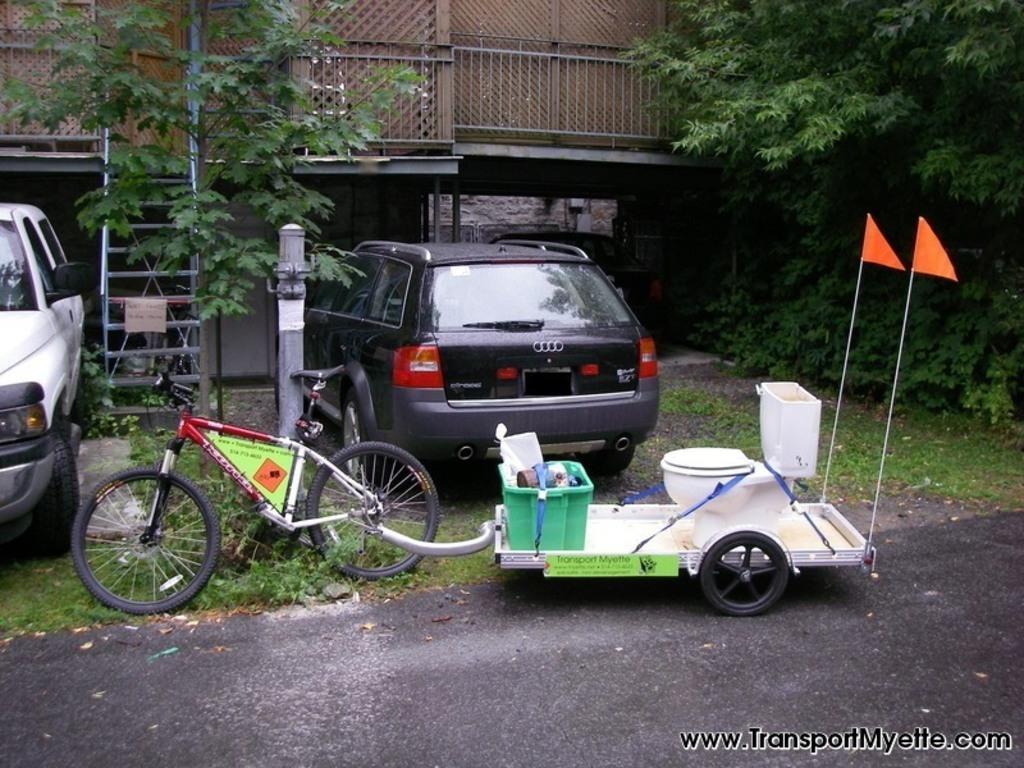How would you summarize this image in a sentence or two? In this image in front there is a road. There is a cycle. There are cars. In the background of the image there are trees, building. There is a ladder. There is some text on the right side of the image. 